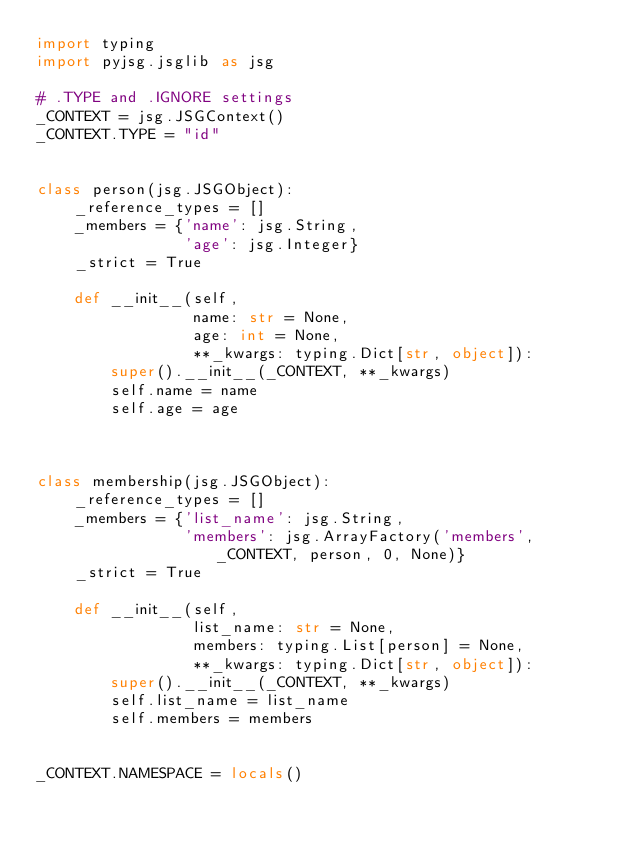<code> <loc_0><loc_0><loc_500><loc_500><_Python_>import typing
import pyjsg.jsglib as jsg

# .TYPE and .IGNORE settings
_CONTEXT = jsg.JSGContext()
_CONTEXT.TYPE = "id"


class person(jsg.JSGObject):
    _reference_types = []
    _members = {'name': jsg.String,
                'age': jsg.Integer}
    _strict = True

    def __init__(self,
                 name: str = None,
                 age: int = None,
                 **_kwargs: typing.Dict[str, object]):
        super().__init__(_CONTEXT, **_kwargs)
        self.name = name
        self.age = age



class membership(jsg.JSGObject):
    _reference_types = []
    _members = {'list_name': jsg.String,
                'members': jsg.ArrayFactory('members', _CONTEXT, person, 0, None)}
    _strict = True

    def __init__(self,
                 list_name: str = None,
                 members: typing.List[person] = None,
                 **_kwargs: typing.Dict[str, object]):
        super().__init__(_CONTEXT, **_kwargs)
        self.list_name = list_name
        self.members = members


_CONTEXT.NAMESPACE = locals()
</code> 